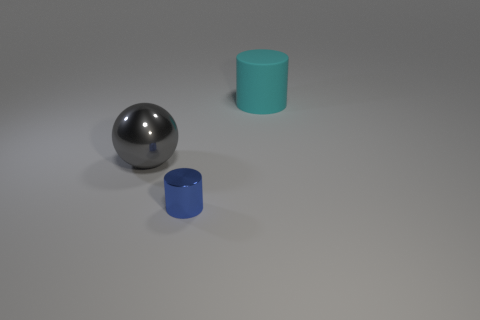Is there anything else that has the same material as the large cyan object?
Offer a terse response. No. There is a ball that is the same size as the cyan cylinder; what is its color?
Keep it short and to the point. Gray. Is the small object the same shape as the rubber thing?
Give a very brief answer. Yes. There is a object that is left of the tiny metallic cylinder; what is it made of?
Keep it short and to the point. Metal. The shiny sphere is what color?
Give a very brief answer. Gray. Do the thing behind the large gray thing and the metallic sphere that is on the left side of the tiny metal cylinder have the same size?
Ensure brevity in your answer.  Yes. There is a thing that is both behind the blue shiny cylinder and in front of the large cylinder; how big is it?
Give a very brief answer. Large. There is another object that is the same shape as the small metal object; what is its color?
Your response must be concise. Cyan. Are there more large cyan cylinders that are behind the metal cylinder than matte objects behind the gray thing?
Keep it short and to the point. No. How many other objects are the same shape as the large cyan object?
Your answer should be very brief. 1. 